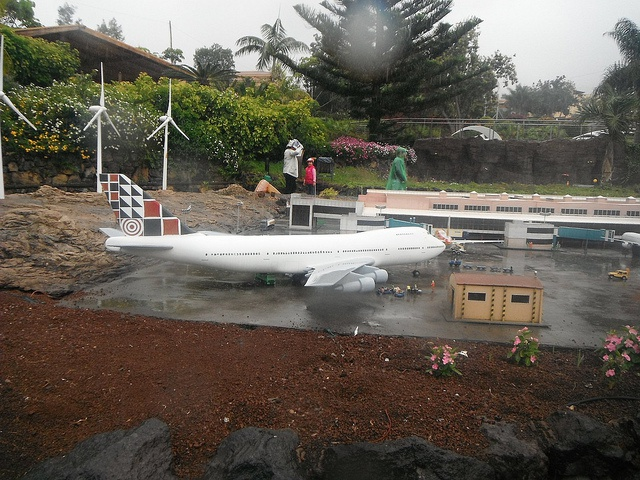Describe the objects in this image and their specific colors. I can see airplane in olive, lightgray, darkgray, gray, and brown tones, potted plant in olive, black, gray, darkgreen, and brown tones, potted plant in olive, black, darkgreen, maroon, and gray tones, potted plant in olive, darkgreen, black, gray, and brown tones, and people in olive, darkgray, black, lightgray, and gray tones in this image. 